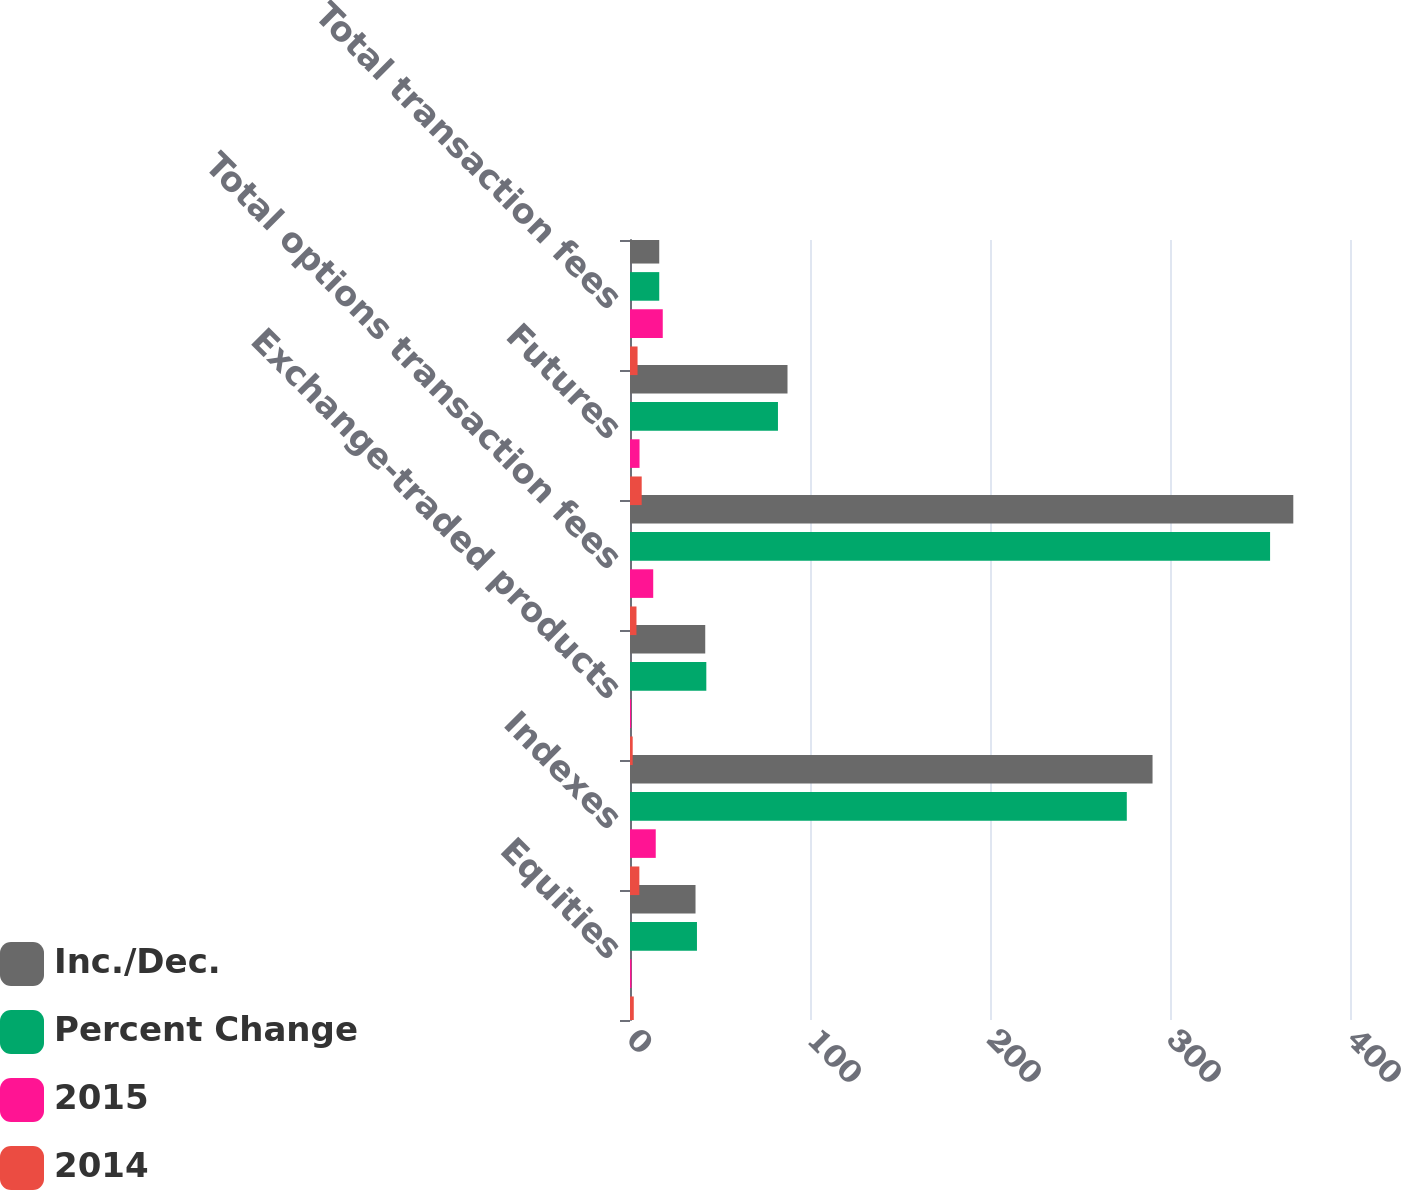<chart> <loc_0><loc_0><loc_500><loc_500><stacked_bar_chart><ecel><fcel>Equities<fcel>Indexes<fcel>Exchange-traded products<fcel>Total options transaction fees<fcel>Futures<fcel>Total transaction fees<nl><fcel>Inc./Dec.<fcel>36.4<fcel>290.3<fcel>41.8<fcel>368.5<fcel>87.5<fcel>16.25<nl><fcel>Percent Change<fcel>37.2<fcel>276<fcel>42.4<fcel>355.6<fcel>82.2<fcel>16.25<nl><fcel>2015<fcel>0.8<fcel>14.3<fcel>0.6<fcel>12.9<fcel>5.3<fcel>18.2<nl><fcel>2014<fcel>2.1<fcel>5.2<fcel>1.5<fcel>3.6<fcel>6.5<fcel>4.2<nl></chart> 